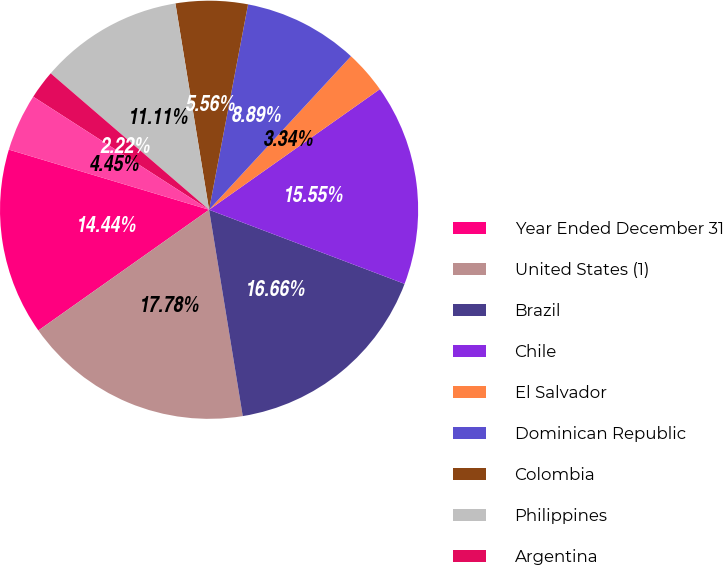Convert chart to OTSL. <chart><loc_0><loc_0><loc_500><loc_500><pie_chart><fcel>Year Ended December 31<fcel>United States (1)<fcel>Brazil<fcel>Chile<fcel>El Salvador<fcel>Dominican Republic<fcel>Colombia<fcel>Philippines<fcel>Argentina<fcel>United Kingdom<nl><fcel>14.44%<fcel>17.78%<fcel>16.66%<fcel>15.55%<fcel>3.34%<fcel>8.89%<fcel>5.56%<fcel>11.11%<fcel>2.22%<fcel>4.45%<nl></chart> 